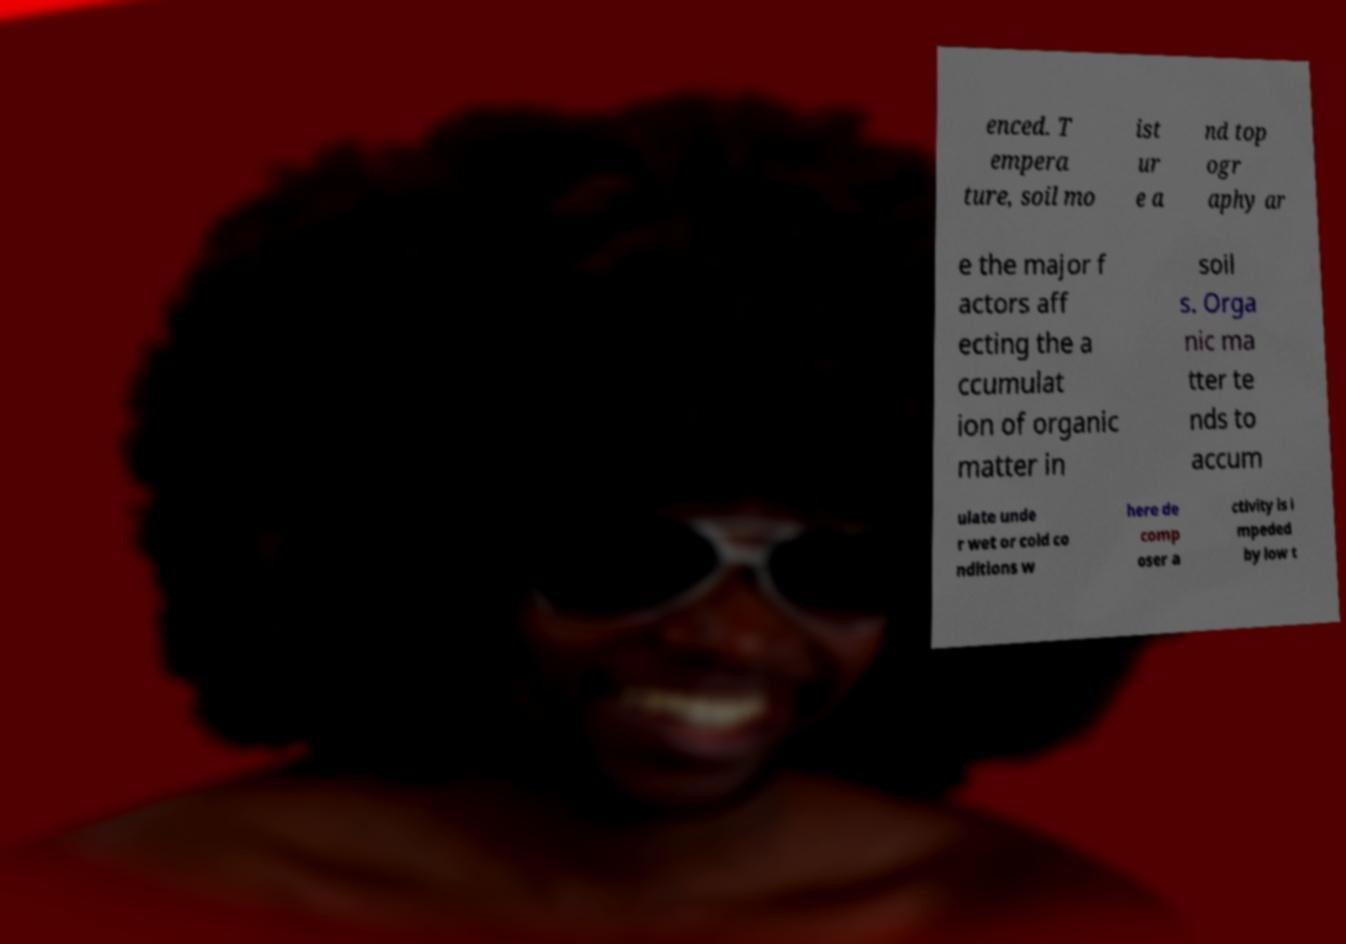Could you extract and type out the text from this image? enced. T empera ture, soil mo ist ur e a nd top ogr aphy ar e the major f actors aff ecting the a ccumulat ion of organic matter in soil s. Orga nic ma tter te nds to accum ulate unde r wet or cold co nditions w here de comp oser a ctivity is i mpeded by low t 